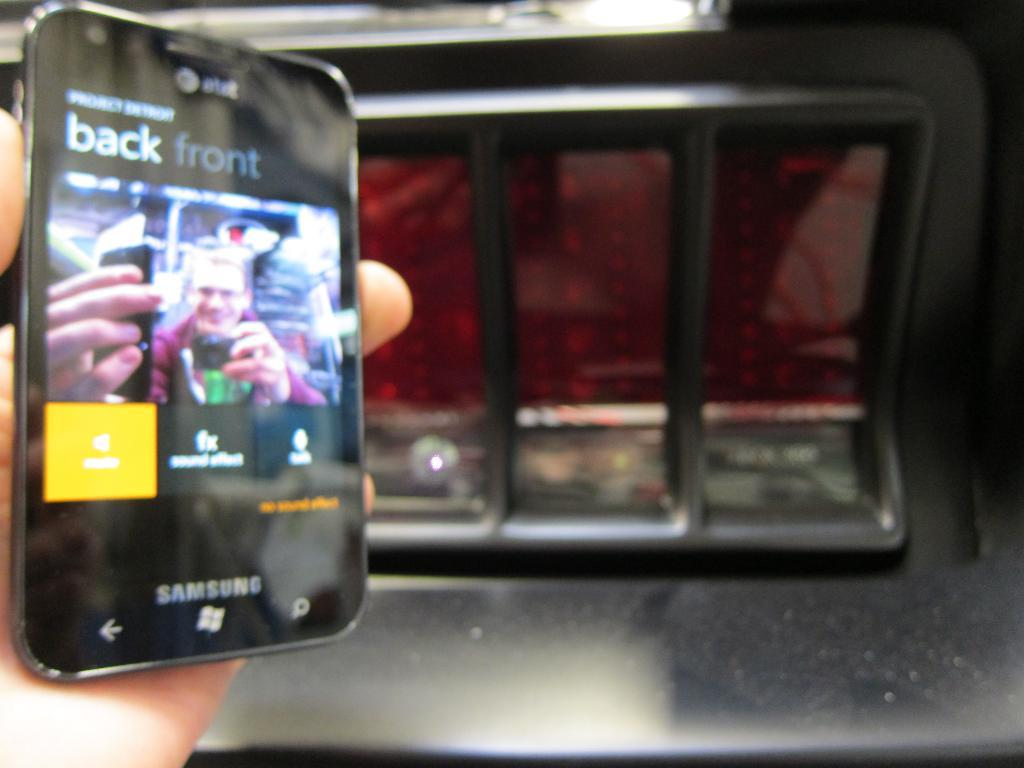Provide a one-sentence caption for the provided image. a SAMSUNG tablet with 'back front' on the screen of it. 